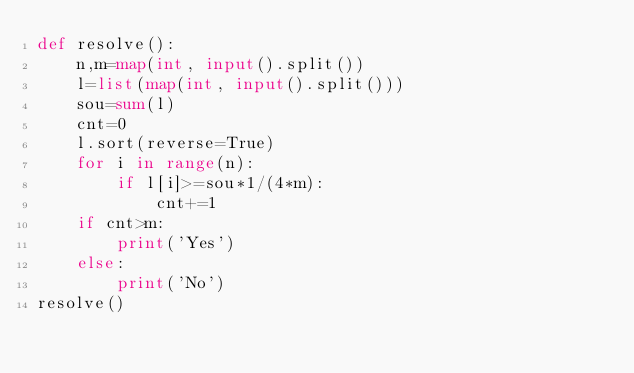Convert code to text. <code><loc_0><loc_0><loc_500><loc_500><_Python_>def resolve():
    n,m=map(int, input().split())
    l=list(map(int, input().split()))
    sou=sum(l)
    cnt=0
    l.sort(reverse=True)
    for i in range(n):
        if l[i]>=sou*1/(4*m):
            cnt+=1
    if cnt>m:
        print('Yes')
    else:
        print('No')
resolve()</code> 